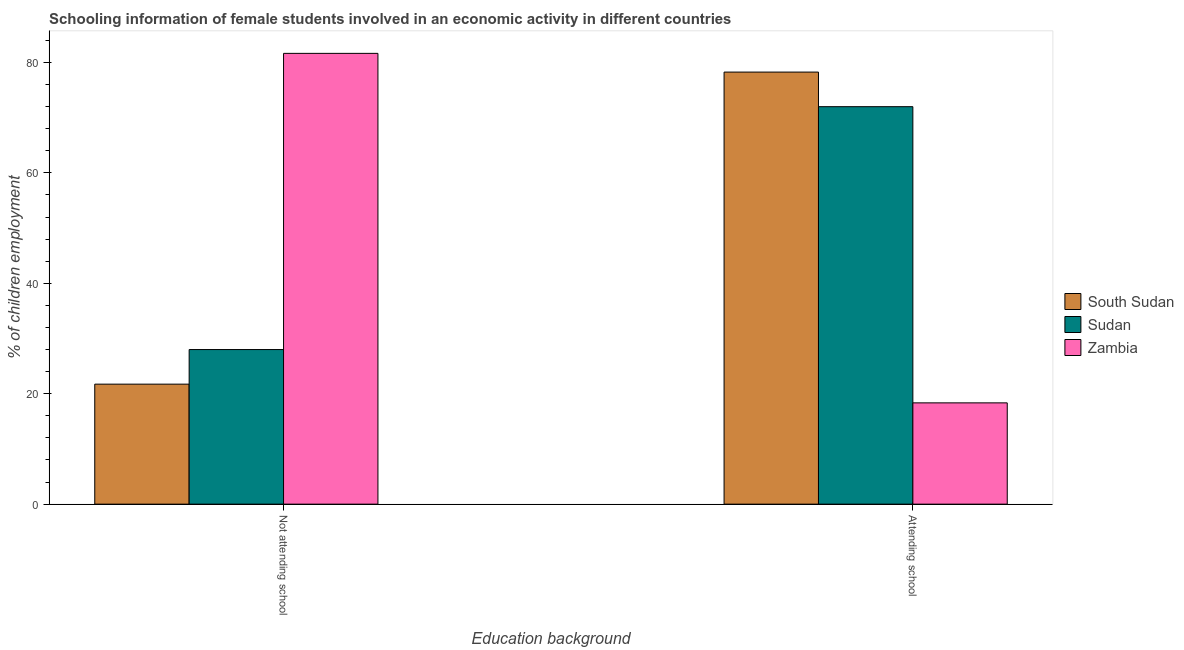How many different coloured bars are there?
Ensure brevity in your answer.  3. Are the number of bars per tick equal to the number of legend labels?
Ensure brevity in your answer.  Yes. Are the number of bars on each tick of the X-axis equal?
Provide a succinct answer. Yes. How many bars are there on the 1st tick from the right?
Your answer should be very brief. 3. What is the label of the 2nd group of bars from the left?
Provide a succinct answer. Attending school. What is the percentage of employed females who are not attending school in Zambia?
Your response must be concise. 81.65. Across all countries, what is the maximum percentage of employed females who are not attending school?
Your answer should be compact. 81.65. Across all countries, what is the minimum percentage of employed females who are not attending school?
Give a very brief answer. 21.74. In which country was the percentage of employed females who are attending school maximum?
Offer a very short reply. South Sudan. In which country was the percentage of employed females who are attending school minimum?
Make the answer very short. Zambia. What is the total percentage of employed females who are not attending school in the graph?
Give a very brief answer. 131.39. What is the difference between the percentage of employed females who are attending school in Zambia and that in South Sudan?
Keep it short and to the point. -59.92. What is the difference between the percentage of employed females who are not attending school in South Sudan and the percentage of employed females who are attending school in Zambia?
Offer a terse response. 3.39. What is the average percentage of employed females who are not attending school per country?
Provide a succinct answer. 43.8. What is the difference between the percentage of employed females who are attending school and percentage of employed females who are not attending school in Zambia?
Give a very brief answer. -63.31. What is the ratio of the percentage of employed females who are attending school in South Sudan to that in Zambia?
Offer a terse response. 4.27. What does the 2nd bar from the left in Attending school represents?
Ensure brevity in your answer.  Sudan. What does the 3rd bar from the right in Attending school represents?
Provide a succinct answer. South Sudan. How many bars are there?
Provide a succinct answer. 6. Are all the bars in the graph horizontal?
Offer a terse response. No. Are the values on the major ticks of Y-axis written in scientific E-notation?
Provide a succinct answer. No. How many legend labels are there?
Offer a terse response. 3. What is the title of the graph?
Offer a very short reply. Schooling information of female students involved in an economic activity in different countries. What is the label or title of the X-axis?
Your response must be concise. Education background. What is the label or title of the Y-axis?
Your answer should be very brief. % of children employment. What is the % of children employment in South Sudan in Not attending school?
Your response must be concise. 21.74. What is the % of children employment of Sudan in Not attending school?
Provide a short and direct response. 28. What is the % of children employment of Zambia in Not attending school?
Ensure brevity in your answer.  81.65. What is the % of children employment of South Sudan in Attending school?
Offer a terse response. 78.26. What is the % of children employment of Sudan in Attending school?
Your answer should be very brief. 72. What is the % of children employment in Zambia in Attending school?
Keep it short and to the point. 18.35. Across all Education background, what is the maximum % of children employment in South Sudan?
Provide a short and direct response. 78.26. Across all Education background, what is the maximum % of children employment in Sudan?
Your answer should be very brief. 72. Across all Education background, what is the maximum % of children employment in Zambia?
Offer a very short reply. 81.65. Across all Education background, what is the minimum % of children employment in South Sudan?
Offer a terse response. 21.74. Across all Education background, what is the minimum % of children employment in Sudan?
Your response must be concise. 28. Across all Education background, what is the minimum % of children employment of Zambia?
Give a very brief answer. 18.35. What is the difference between the % of children employment of South Sudan in Not attending school and that in Attending school?
Ensure brevity in your answer.  -56.53. What is the difference between the % of children employment in Sudan in Not attending school and that in Attending school?
Your answer should be compact. -43.99. What is the difference between the % of children employment of Zambia in Not attending school and that in Attending school?
Your answer should be very brief. 63.31. What is the difference between the % of children employment of South Sudan in Not attending school and the % of children employment of Sudan in Attending school?
Your answer should be very brief. -50.26. What is the difference between the % of children employment of South Sudan in Not attending school and the % of children employment of Zambia in Attending school?
Offer a very short reply. 3.39. What is the difference between the % of children employment in Sudan in Not attending school and the % of children employment in Zambia in Attending school?
Keep it short and to the point. 9.66. What is the difference between the % of children employment of South Sudan and % of children employment of Sudan in Not attending school?
Provide a succinct answer. -6.27. What is the difference between the % of children employment of South Sudan and % of children employment of Zambia in Not attending school?
Give a very brief answer. -59.92. What is the difference between the % of children employment in Sudan and % of children employment in Zambia in Not attending school?
Ensure brevity in your answer.  -53.65. What is the difference between the % of children employment in South Sudan and % of children employment in Sudan in Attending school?
Your answer should be very brief. 6.27. What is the difference between the % of children employment of South Sudan and % of children employment of Zambia in Attending school?
Make the answer very short. 59.92. What is the difference between the % of children employment of Sudan and % of children employment of Zambia in Attending school?
Offer a very short reply. 53.65. What is the ratio of the % of children employment of South Sudan in Not attending school to that in Attending school?
Give a very brief answer. 0.28. What is the ratio of the % of children employment in Sudan in Not attending school to that in Attending school?
Ensure brevity in your answer.  0.39. What is the ratio of the % of children employment of Zambia in Not attending school to that in Attending school?
Provide a succinct answer. 4.45. What is the difference between the highest and the second highest % of children employment in South Sudan?
Offer a very short reply. 56.53. What is the difference between the highest and the second highest % of children employment in Sudan?
Make the answer very short. 43.99. What is the difference between the highest and the second highest % of children employment in Zambia?
Ensure brevity in your answer.  63.31. What is the difference between the highest and the lowest % of children employment in South Sudan?
Ensure brevity in your answer.  56.53. What is the difference between the highest and the lowest % of children employment in Sudan?
Your response must be concise. 43.99. What is the difference between the highest and the lowest % of children employment of Zambia?
Provide a short and direct response. 63.31. 